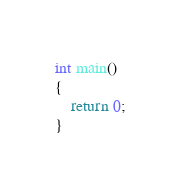<code> <loc_0><loc_0><loc_500><loc_500><_C++_>
int main()
{
	return 0;
}</code> 